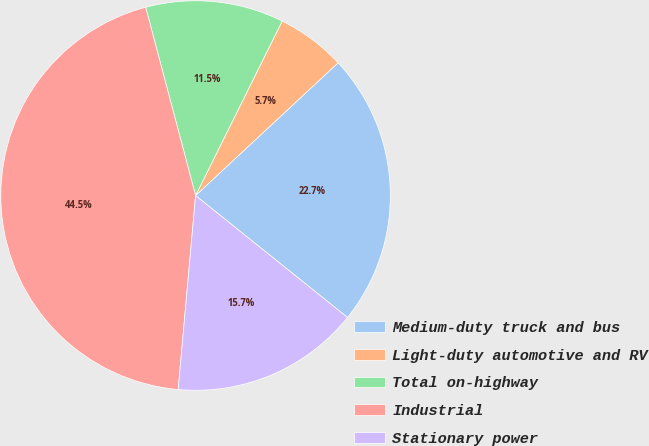Convert chart to OTSL. <chart><loc_0><loc_0><loc_500><loc_500><pie_chart><fcel>Medium-duty truck and bus<fcel>Light-duty automotive and RV<fcel>Total on-highway<fcel>Industrial<fcel>Stationary power<nl><fcel>22.7%<fcel>5.73%<fcel>11.46%<fcel>44.45%<fcel>15.66%<nl></chart> 